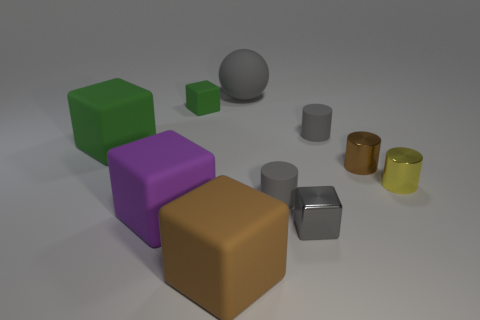There is a green thing that is the same size as the yellow metal cylinder; what is its material?
Your answer should be very brief. Rubber. What is the gray thing that is behind the small yellow shiny thing and on the right side of the big gray rubber thing made of?
Make the answer very short. Rubber. Are there any tiny gray cylinders that are in front of the gray ball that is behind the small yellow cylinder?
Your response must be concise. Yes. There is a block that is on the right side of the tiny matte cube and to the left of the large matte ball; how big is it?
Make the answer very short. Large. How many brown objects are either metal things or small cylinders?
Your answer should be compact. 1. What is the shape of the brown metal thing that is the same size as the yellow thing?
Provide a short and direct response. Cylinder. What number of other objects are the same color as the large rubber ball?
Offer a terse response. 3. There is a brown thing that is left of the large matte thing that is right of the brown rubber object; what is its size?
Keep it short and to the point. Large. Is the material of the brown object behind the purple thing the same as the large gray thing?
Make the answer very short. No. There is a brown object that is on the right side of the brown matte block; what shape is it?
Your answer should be very brief. Cylinder. 